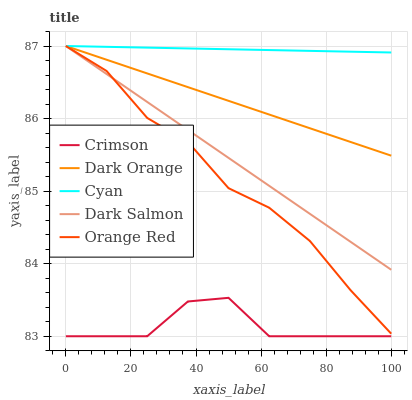Does Crimson have the minimum area under the curve?
Answer yes or no. Yes. Does Cyan have the maximum area under the curve?
Answer yes or no. Yes. Does Dark Orange have the minimum area under the curve?
Answer yes or no. No. Does Dark Orange have the maximum area under the curve?
Answer yes or no. No. Is Cyan the smoothest?
Answer yes or no. Yes. Is Crimson the roughest?
Answer yes or no. Yes. Is Dark Orange the smoothest?
Answer yes or no. No. Is Dark Orange the roughest?
Answer yes or no. No. Does Crimson have the lowest value?
Answer yes or no. Yes. Does Dark Orange have the lowest value?
Answer yes or no. No. Does Cyan have the highest value?
Answer yes or no. Yes. Is Crimson less than Dark Salmon?
Answer yes or no. Yes. Is Orange Red greater than Crimson?
Answer yes or no. Yes. Does Dark Orange intersect Orange Red?
Answer yes or no. Yes. Is Dark Orange less than Orange Red?
Answer yes or no. No. Is Dark Orange greater than Orange Red?
Answer yes or no. No. Does Crimson intersect Dark Salmon?
Answer yes or no. No. 